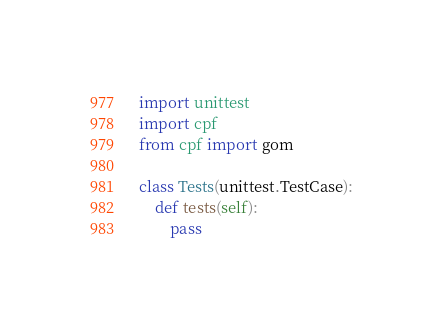<code> <loc_0><loc_0><loc_500><loc_500><_Python_>import unittest
import cpf
from cpf import gom

class Tests(unittest.TestCase):
	def tests(self):
		pass
</code> 